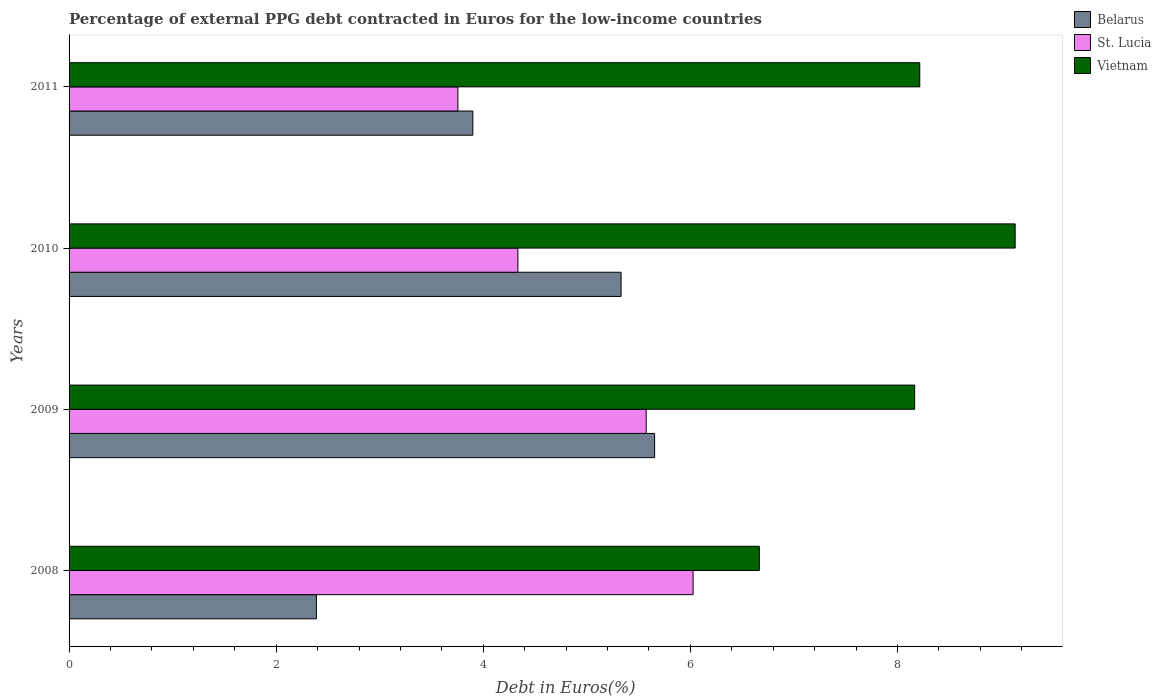Are the number of bars per tick equal to the number of legend labels?
Give a very brief answer. Yes. Are the number of bars on each tick of the Y-axis equal?
Give a very brief answer. Yes. What is the percentage of external PPG debt contracted in Euros in Belarus in 2011?
Your answer should be compact. 3.9. Across all years, what is the maximum percentage of external PPG debt contracted in Euros in St. Lucia?
Your answer should be compact. 6.03. Across all years, what is the minimum percentage of external PPG debt contracted in Euros in St. Lucia?
Provide a short and direct response. 3.75. In which year was the percentage of external PPG debt contracted in Euros in Vietnam maximum?
Make the answer very short. 2010. What is the total percentage of external PPG debt contracted in Euros in Vietnam in the graph?
Offer a terse response. 32.18. What is the difference between the percentage of external PPG debt contracted in Euros in Belarus in 2008 and that in 2009?
Make the answer very short. -3.27. What is the difference between the percentage of external PPG debt contracted in Euros in Vietnam in 2010 and the percentage of external PPG debt contracted in Euros in Belarus in 2011?
Give a very brief answer. 5.24. What is the average percentage of external PPG debt contracted in Euros in St. Lucia per year?
Ensure brevity in your answer.  4.92. In the year 2008, what is the difference between the percentage of external PPG debt contracted in Euros in Belarus and percentage of external PPG debt contracted in Euros in Vietnam?
Offer a very short reply. -4.28. In how many years, is the percentage of external PPG debt contracted in Euros in Belarus greater than 2 %?
Your answer should be compact. 4. What is the ratio of the percentage of external PPG debt contracted in Euros in Belarus in 2008 to that in 2009?
Your answer should be very brief. 0.42. What is the difference between the highest and the second highest percentage of external PPG debt contracted in Euros in St. Lucia?
Offer a very short reply. 0.45. What is the difference between the highest and the lowest percentage of external PPG debt contracted in Euros in St. Lucia?
Your response must be concise. 2.27. What does the 1st bar from the top in 2008 represents?
Offer a terse response. Vietnam. What does the 2nd bar from the bottom in 2009 represents?
Offer a terse response. St. Lucia. How many bars are there?
Offer a very short reply. 12. Are all the bars in the graph horizontal?
Give a very brief answer. Yes. What is the difference between two consecutive major ticks on the X-axis?
Offer a very short reply. 2. Are the values on the major ticks of X-axis written in scientific E-notation?
Make the answer very short. No. Where does the legend appear in the graph?
Your answer should be very brief. Top right. What is the title of the graph?
Your response must be concise. Percentage of external PPG debt contracted in Euros for the low-income countries. Does "Morocco" appear as one of the legend labels in the graph?
Your response must be concise. No. What is the label or title of the X-axis?
Offer a terse response. Debt in Euros(%). What is the label or title of the Y-axis?
Make the answer very short. Years. What is the Debt in Euros(%) in Belarus in 2008?
Keep it short and to the point. 2.39. What is the Debt in Euros(%) of St. Lucia in 2008?
Offer a terse response. 6.03. What is the Debt in Euros(%) of Vietnam in 2008?
Your answer should be very brief. 6.67. What is the Debt in Euros(%) in Belarus in 2009?
Provide a short and direct response. 5.65. What is the Debt in Euros(%) in St. Lucia in 2009?
Your response must be concise. 5.57. What is the Debt in Euros(%) of Vietnam in 2009?
Provide a succinct answer. 8.17. What is the Debt in Euros(%) in Belarus in 2010?
Offer a very short reply. 5.33. What is the Debt in Euros(%) in St. Lucia in 2010?
Provide a succinct answer. 4.33. What is the Debt in Euros(%) in Vietnam in 2010?
Your response must be concise. 9.14. What is the Debt in Euros(%) in Belarus in 2011?
Ensure brevity in your answer.  3.9. What is the Debt in Euros(%) of St. Lucia in 2011?
Provide a succinct answer. 3.75. What is the Debt in Euros(%) of Vietnam in 2011?
Offer a very short reply. 8.22. Across all years, what is the maximum Debt in Euros(%) of Belarus?
Your response must be concise. 5.65. Across all years, what is the maximum Debt in Euros(%) of St. Lucia?
Make the answer very short. 6.03. Across all years, what is the maximum Debt in Euros(%) in Vietnam?
Provide a short and direct response. 9.14. Across all years, what is the minimum Debt in Euros(%) of Belarus?
Make the answer very short. 2.39. Across all years, what is the minimum Debt in Euros(%) in St. Lucia?
Keep it short and to the point. 3.75. Across all years, what is the minimum Debt in Euros(%) in Vietnam?
Your answer should be compact. 6.67. What is the total Debt in Euros(%) of Belarus in the graph?
Your answer should be compact. 17.27. What is the total Debt in Euros(%) of St. Lucia in the graph?
Your answer should be compact. 19.69. What is the total Debt in Euros(%) in Vietnam in the graph?
Make the answer very short. 32.18. What is the difference between the Debt in Euros(%) of Belarus in 2008 and that in 2009?
Your answer should be very brief. -3.27. What is the difference between the Debt in Euros(%) in St. Lucia in 2008 and that in 2009?
Ensure brevity in your answer.  0.45. What is the difference between the Debt in Euros(%) in Vietnam in 2008 and that in 2009?
Offer a terse response. -1.5. What is the difference between the Debt in Euros(%) in Belarus in 2008 and that in 2010?
Your response must be concise. -2.94. What is the difference between the Debt in Euros(%) in St. Lucia in 2008 and that in 2010?
Offer a terse response. 1.69. What is the difference between the Debt in Euros(%) in Vietnam in 2008 and that in 2010?
Ensure brevity in your answer.  -2.47. What is the difference between the Debt in Euros(%) in Belarus in 2008 and that in 2011?
Offer a terse response. -1.51. What is the difference between the Debt in Euros(%) of St. Lucia in 2008 and that in 2011?
Offer a very short reply. 2.27. What is the difference between the Debt in Euros(%) of Vietnam in 2008 and that in 2011?
Provide a short and direct response. -1.55. What is the difference between the Debt in Euros(%) in Belarus in 2009 and that in 2010?
Give a very brief answer. 0.32. What is the difference between the Debt in Euros(%) in St. Lucia in 2009 and that in 2010?
Your answer should be compact. 1.24. What is the difference between the Debt in Euros(%) of Vietnam in 2009 and that in 2010?
Your response must be concise. -0.97. What is the difference between the Debt in Euros(%) of Belarus in 2009 and that in 2011?
Your response must be concise. 1.76. What is the difference between the Debt in Euros(%) in St. Lucia in 2009 and that in 2011?
Ensure brevity in your answer.  1.82. What is the difference between the Debt in Euros(%) of Vietnam in 2009 and that in 2011?
Provide a short and direct response. -0.05. What is the difference between the Debt in Euros(%) in Belarus in 2010 and that in 2011?
Your answer should be compact. 1.43. What is the difference between the Debt in Euros(%) of St. Lucia in 2010 and that in 2011?
Provide a succinct answer. 0.58. What is the difference between the Debt in Euros(%) in Vietnam in 2010 and that in 2011?
Your answer should be very brief. 0.92. What is the difference between the Debt in Euros(%) of Belarus in 2008 and the Debt in Euros(%) of St. Lucia in 2009?
Provide a succinct answer. -3.19. What is the difference between the Debt in Euros(%) in Belarus in 2008 and the Debt in Euros(%) in Vietnam in 2009?
Ensure brevity in your answer.  -5.78. What is the difference between the Debt in Euros(%) of St. Lucia in 2008 and the Debt in Euros(%) of Vietnam in 2009?
Offer a very short reply. -2.14. What is the difference between the Debt in Euros(%) of Belarus in 2008 and the Debt in Euros(%) of St. Lucia in 2010?
Offer a terse response. -1.95. What is the difference between the Debt in Euros(%) in Belarus in 2008 and the Debt in Euros(%) in Vietnam in 2010?
Keep it short and to the point. -6.75. What is the difference between the Debt in Euros(%) in St. Lucia in 2008 and the Debt in Euros(%) in Vietnam in 2010?
Ensure brevity in your answer.  -3.11. What is the difference between the Debt in Euros(%) in Belarus in 2008 and the Debt in Euros(%) in St. Lucia in 2011?
Your answer should be compact. -1.37. What is the difference between the Debt in Euros(%) in Belarus in 2008 and the Debt in Euros(%) in Vietnam in 2011?
Provide a short and direct response. -5.83. What is the difference between the Debt in Euros(%) in St. Lucia in 2008 and the Debt in Euros(%) in Vietnam in 2011?
Offer a very short reply. -2.19. What is the difference between the Debt in Euros(%) of Belarus in 2009 and the Debt in Euros(%) of St. Lucia in 2010?
Offer a terse response. 1.32. What is the difference between the Debt in Euros(%) of Belarus in 2009 and the Debt in Euros(%) of Vietnam in 2010?
Keep it short and to the point. -3.48. What is the difference between the Debt in Euros(%) in St. Lucia in 2009 and the Debt in Euros(%) in Vietnam in 2010?
Ensure brevity in your answer.  -3.56. What is the difference between the Debt in Euros(%) of Belarus in 2009 and the Debt in Euros(%) of St. Lucia in 2011?
Give a very brief answer. 1.9. What is the difference between the Debt in Euros(%) in Belarus in 2009 and the Debt in Euros(%) in Vietnam in 2011?
Your answer should be very brief. -2.56. What is the difference between the Debt in Euros(%) in St. Lucia in 2009 and the Debt in Euros(%) in Vietnam in 2011?
Your answer should be very brief. -2.64. What is the difference between the Debt in Euros(%) in Belarus in 2010 and the Debt in Euros(%) in St. Lucia in 2011?
Provide a short and direct response. 1.58. What is the difference between the Debt in Euros(%) of Belarus in 2010 and the Debt in Euros(%) of Vietnam in 2011?
Make the answer very short. -2.88. What is the difference between the Debt in Euros(%) in St. Lucia in 2010 and the Debt in Euros(%) in Vietnam in 2011?
Your response must be concise. -3.88. What is the average Debt in Euros(%) in Belarus per year?
Provide a succinct answer. 4.32. What is the average Debt in Euros(%) of St. Lucia per year?
Give a very brief answer. 4.92. What is the average Debt in Euros(%) in Vietnam per year?
Ensure brevity in your answer.  8.05. In the year 2008, what is the difference between the Debt in Euros(%) in Belarus and Debt in Euros(%) in St. Lucia?
Give a very brief answer. -3.64. In the year 2008, what is the difference between the Debt in Euros(%) of Belarus and Debt in Euros(%) of Vietnam?
Ensure brevity in your answer.  -4.28. In the year 2008, what is the difference between the Debt in Euros(%) in St. Lucia and Debt in Euros(%) in Vietnam?
Make the answer very short. -0.64. In the year 2009, what is the difference between the Debt in Euros(%) of Belarus and Debt in Euros(%) of St. Lucia?
Give a very brief answer. 0.08. In the year 2009, what is the difference between the Debt in Euros(%) of Belarus and Debt in Euros(%) of Vietnam?
Your response must be concise. -2.51. In the year 2009, what is the difference between the Debt in Euros(%) of St. Lucia and Debt in Euros(%) of Vietnam?
Provide a succinct answer. -2.59. In the year 2010, what is the difference between the Debt in Euros(%) of Belarus and Debt in Euros(%) of St. Lucia?
Keep it short and to the point. 1. In the year 2010, what is the difference between the Debt in Euros(%) in Belarus and Debt in Euros(%) in Vietnam?
Offer a very short reply. -3.81. In the year 2010, what is the difference between the Debt in Euros(%) in St. Lucia and Debt in Euros(%) in Vietnam?
Make the answer very short. -4.8. In the year 2011, what is the difference between the Debt in Euros(%) of Belarus and Debt in Euros(%) of St. Lucia?
Your response must be concise. 0.14. In the year 2011, what is the difference between the Debt in Euros(%) in Belarus and Debt in Euros(%) in Vietnam?
Make the answer very short. -4.32. In the year 2011, what is the difference between the Debt in Euros(%) in St. Lucia and Debt in Euros(%) in Vietnam?
Your answer should be compact. -4.46. What is the ratio of the Debt in Euros(%) in Belarus in 2008 to that in 2009?
Offer a very short reply. 0.42. What is the ratio of the Debt in Euros(%) of St. Lucia in 2008 to that in 2009?
Ensure brevity in your answer.  1.08. What is the ratio of the Debt in Euros(%) in Vietnam in 2008 to that in 2009?
Your response must be concise. 0.82. What is the ratio of the Debt in Euros(%) in Belarus in 2008 to that in 2010?
Ensure brevity in your answer.  0.45. What is the ratio of the Debt in Euros(%) in St. Lucia in 2008 to that in 2010?
Your answer should be compact. 1.39. What is the ratio of the Debt in Euros(%) in Vietnam in 2008 to that in 2010?
Provide a succinct answer. 0.73. What is the ratio of the Debt in Euros(%) of Belarus in 2008 to that in 2011?
Give a very brief answer. 0.61. What is the ratio of the Debt in Euros(%) in St. Lucia in 2008 to that in 2011?
Make the answer very short. 1.61. What is the ratio of the Debt in Euros(%) of Vietnam in 2008 to that in 2011?
Offer a very short reply. 0.81. What is the ratio of the Debt in Euros(%) of Belarus in 2009 to that in 2010?
Keep it short and to the point. 1.06. What is the ratio of the Debt in Euros(%) in St. Lucia in 2009 to that in 2010?
Your answer should be very brief. 1.29. What is the ratio of the Debt in Euros(%) in Vietnam in 2009 to that in 2010?
Ensure brevity in your answer.  0.89. What is the ratio of the Debt in Euros(%) in Belarus in 2009 to that in 2011?
Offer a very short reply. 1.45. What is the ratio of the Debt in Euros(%) of St. Lucia in 2009 to that in 2011?
Your answer should be very brief. 1.48. What is the ratio of the Debt in Euros(%) of Belarus in 2010 to that in 2011?
Offer a terse response. 1.37. What is the ratio of the Debt in Euros(%) in St. Lucia in 2010 to that in 2011?
Your response must be concise. 1.15. What is the ratio of the Debt in Euros(%) of Vietnam in 2010 to that in 2011?
Provide a succinct answer. 1.11. What is the difference between the highest and the second highest Debt in Euros(%) of Belarus?
Offer a very short reply. 0.32. What is the difference between the highest and the second highest Debt in Euros(%) in St. Lucia?
Make the answer very short. 0.45. What is the difference between the highest and the second highest Debt in Euros(%) in Vietnam?
Offer a terse response. 0.92. What is the difference between the highest and the lowest Debt in Euros(%) of Belarus?
Your answer should be very brief. 3.27. What is the difference between the highest and the lowest Debt in Euros(%) in St. Lucia?
Ensure brevity in your answer.  2.27. What is the difference between the highest and the lowest Debt in Euros(%) in Vietnam?
Your response must be concise. 2.47. 